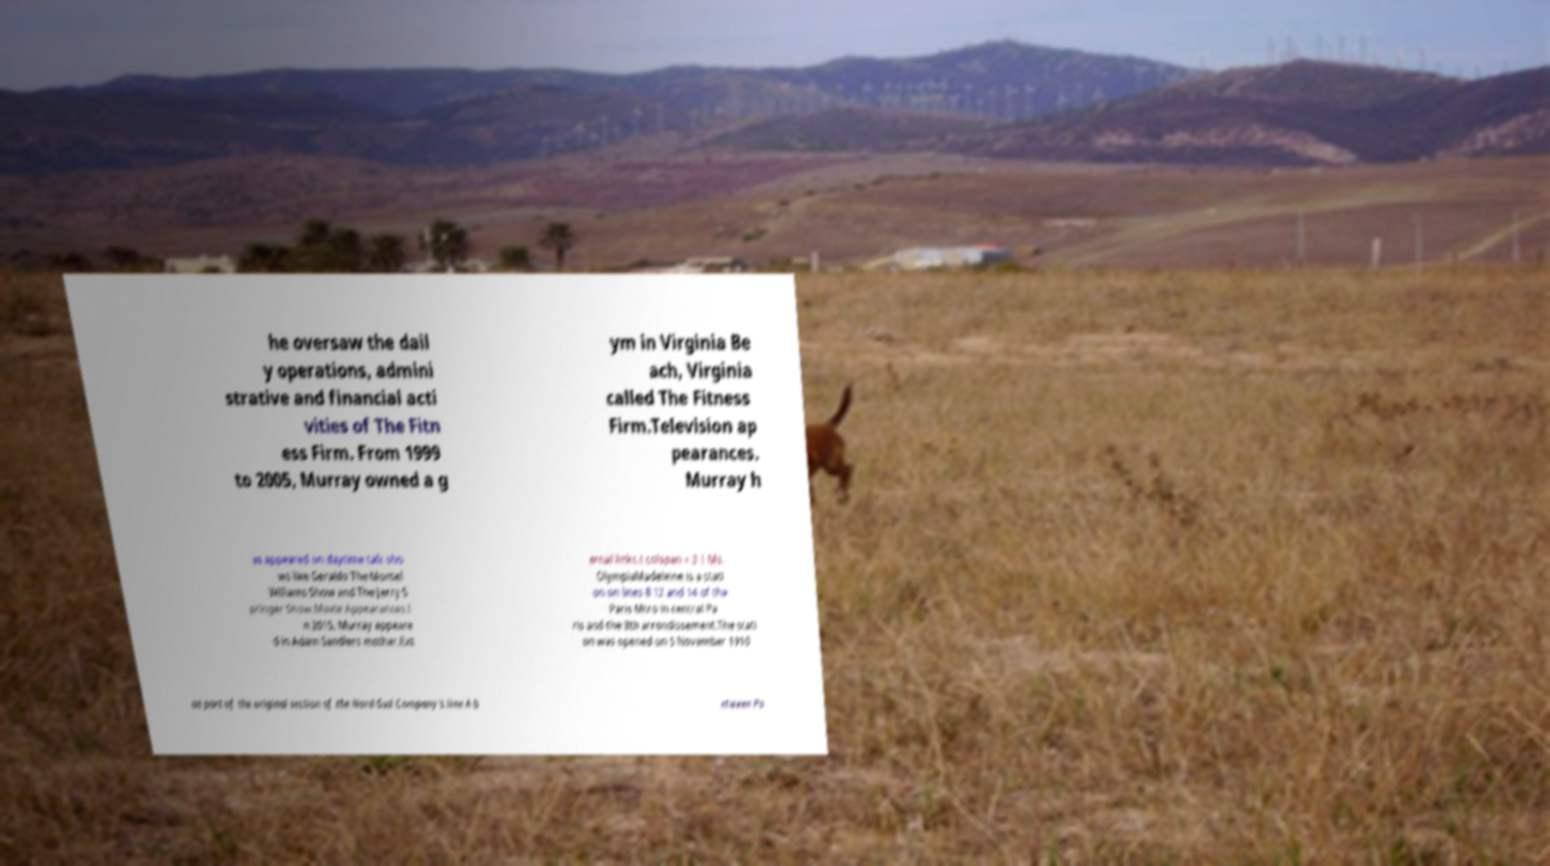Please identify and transcribe the text found in this image. he oversaw the dail y operations, admini strative and financial acti vities of The Fitn ess Firm. From 1999 to 2005, Murray owned a g ym in Virginia Be ach, Virginia called The Fitness Firm.Television ap pearances. Murray h as appeared on daytime talk sho ws like Geraldo The Montel Williams Show and The Jerry S pringer Show.Movie Appearances.I n 2015, Murray appeare d in Adam Sandlers mother.Ext ernal links.! colspan = 3 | Ms. OlympiaMadeleine is a stati on on lines 8 12 and 14 of the Paris Mtro in central Pa ris and the 8th arrondissement.The stati on was opened on 5 November 1910 as part of the original section of the Nord-Sud Company's line A b etween Po 